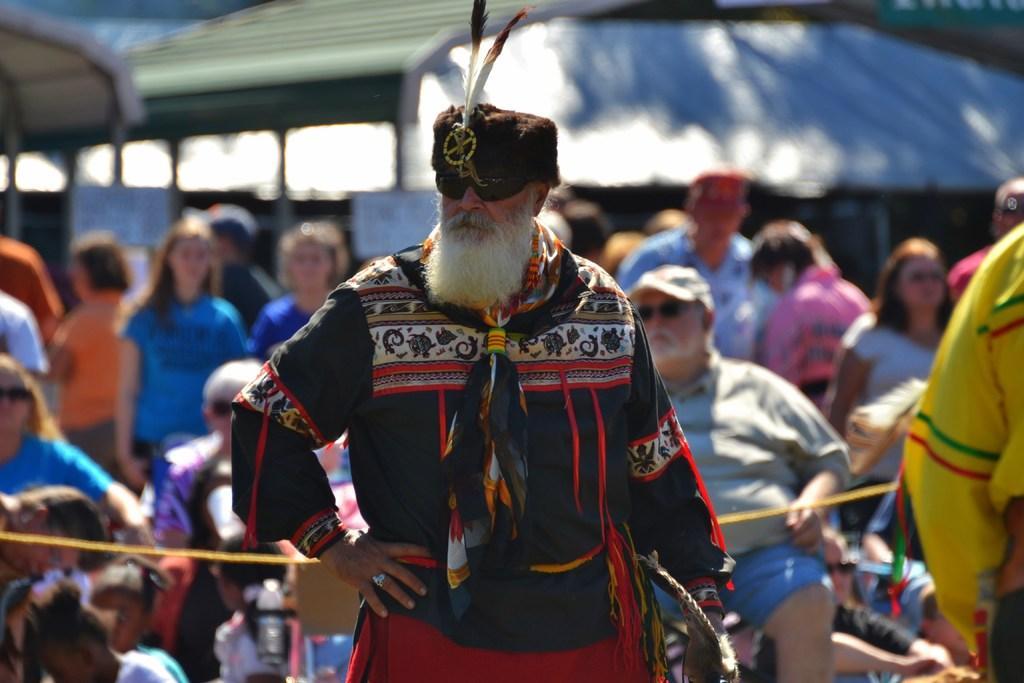Describe this image in one or two sentences. In this picture we can observe a person wearing black and red color dress and a cap on his head. He is wearing spectacles. In the background we can observe some people sitting and standing. There are men and women in this picture. 